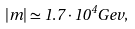<formula> <loc_0><loc_0><loc_500><loc_500>| m | \simeq 1 . 7 \cdot 1 0 ^ { 4 } G e v ,</formula> 